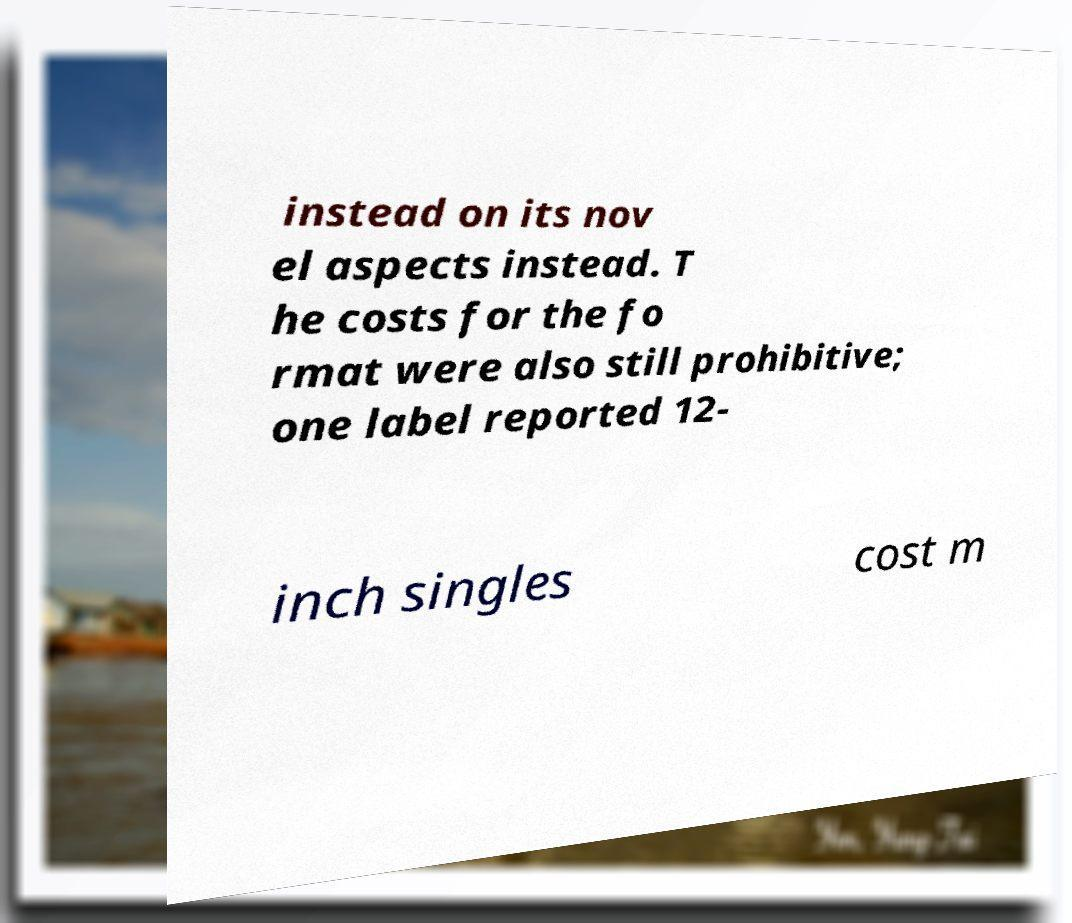Please read and relay the text visible in this image. What does it say? instead on its nov el aspects instead. T he costs for the fo rmat were also still prohibitive; one label reported 12- inch singles cost m 